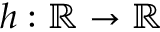<formula> <loc_0><loc_0><loc_500><loc_500>h \colon \mathbb { R } \rightarrow \mathbb { R }</formula> 